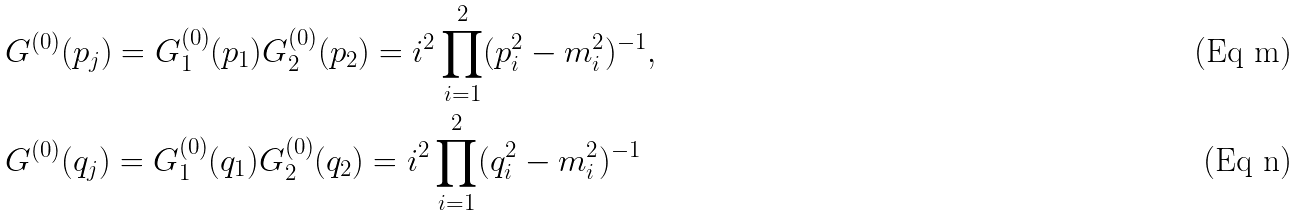Convert formula to latex. <formula><loc_0><loc_0><loc_500><loc_500>& G ^ { ( 0 ) } ( p _ { j } ) = G _ { 1 } ^ { ( 0 ) } ( p _ { 1 } ) G _ { 2 } ^ { ( 0 ) } ( p _ { 2 } ) = i ^ { 2 } \prod _ { i = 1 } ^ { 2 } ( p _ { i } ^ { 2 } - m _ { i } ^ { 2 } ) ^ { - 1 } , \\ & G ^ { ( 0 ) } ( q _ { j } ) = G _ { 1 } ^ { ( 0 ) } ( q _ { 1 } ) G _ { 2 } ^ { ( 0 ) } ( q _ { 2 } ) = i ^ { 2 } \prod _ { i = 1 } ^ { 2 } ( q _ { i } ^ { 2 } - m _ { i } ^ { 2 } ) ^ { - 1 }</formula> 